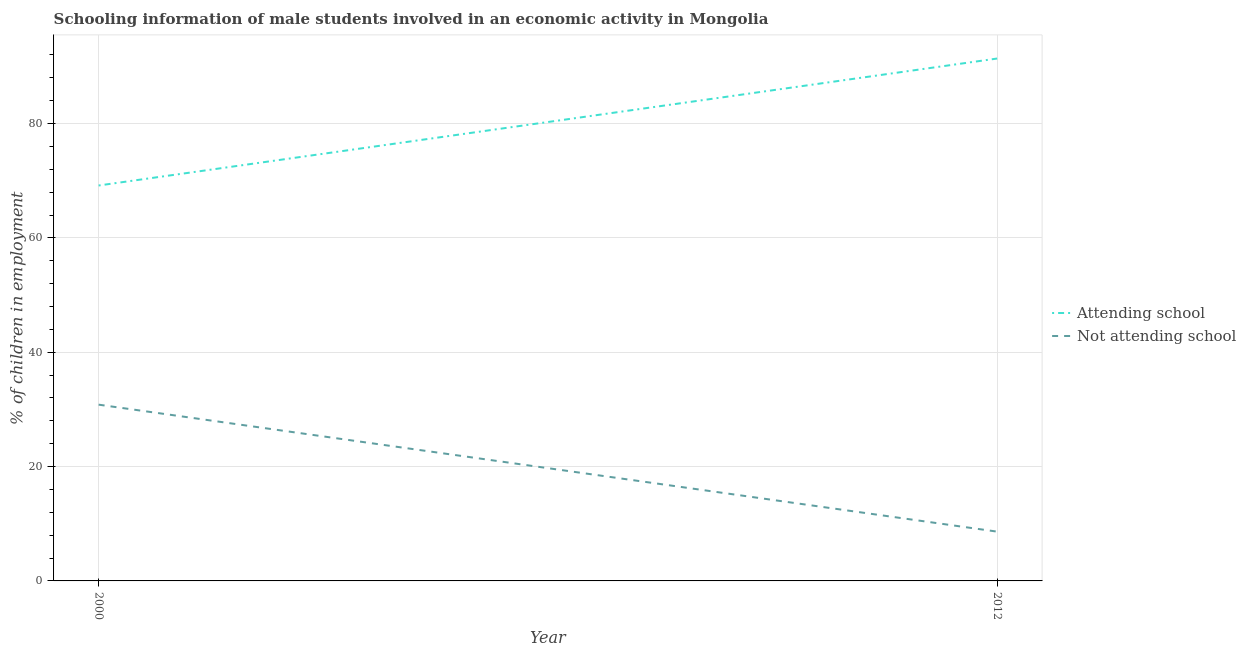How many different coloured lines are there?
Offer a very short reply. 2. Does the line corresponding to percentage of employed males who are not attending school intersect with the line corresponding to percentage of employed males who are attending school?
Keep it short and to the point. No. What is the percentage of employed males who are not attending school in 2012?
Offer a very short reply. 8.62. Across all years, what is the maximum percentage of employed males who are not attending school?
Give a very brief answer. 30.83. Across all years, what is the minimum percentage of employed males who are not attending school?
Make the answer very short. 8.62. What is the total percentage of employed males who are attending school in the graph?
Your response must be concise. 160.55. What is the difference between the percentage of employed males who are not attending school in 2000 and that in 2012?
Offer a terse response. 22.21. What is the difference between the percentage of employed males who are not attending school in 2012 and the percentage of employed males who are attending school in 2000?
Your response must be concise. -60.55. What is the average percentage of employed males who are not attending school per year?
Your response must be concise. 19.73. In the year 2000, what is the difference between the percentage of employed males who are attending school and percentage of employed males who are not attending school?
Your answer should be compact. 38.34. In how many years, is the percentage of employed males who are not attending school greater than 64 %?
Offer a very short reply. 0. What is the ratio of the percentage of employed males who are not attending school in 2000 to that in 2012?
Your answer should be very brief. 3.58. Is the percentage of employed males who are attending school in 2000 less than that in 2012?
Provide a short and direct response. Yes. In how many years, is the percentage of employed males who are not attending school greater than the average percentage of employed males who are not attending school taken over all years?
Ensure brevity in your answer.  1. Does the percentage of employed males who are attending school monotonically increase over the years?
Provide a succinct answer. Yes. Is the percentage of employed males who are attending school strictly greater than the percentage of employed males who are not attending school over the years?
Offer a terse response. Yes. Is the percentage of employed males who are attending school strictly less than the percentage of employed males who are not attending school over the years?
Keep it short and to the point. No. How many years are there in the graph?
Offer a very short reply. 2. Does the graph contain any zero values?
Offer a terse response. No. Where does the legend appear in the graph?
Make the answer very short. Center right. How many legend labels are there?
Your answer should be compact. 2. How are the legend labels stacked?
Your answer should be very brief. Vertical. What is the title of the graph?
Provide a short and direct response. Schooling information of male students involved in an economic activity in Mongolia. Does "Under-5(female)" appear as one of the legend labels in the graph?
Keep it short and to the point. No. What is the label or title of the X-axis?
Provide a short and direct response. Year. What is the label or title of the Y-axis?
Provide a succinct answer. % of children in employment. What is the % of children in employment of Attending school in 2000?
Your answer should be compact. 69.17. What is the % of children in employment in Not attending school in 2000?
Make the answer very short. 30.83. What is the % of children in employment of Attending school in 2012?
Ensure brevity in your answer.  91.38. What is the % of children in employment of Not attending school in 2012?
Make the answer very short. 8.62. Across all years, what is the maximum % of children in employment in Attending school?
Ensure brevity in your answer.  91.38. Across all years, what is the maximum % of children in employment in Not attending school?
Your answer should be very brief. 30.83. Across all years, what is the minimum % of children in employment of Attending school?
Offer a terse response. 69.17. Across all years, what is the minimum % of children in employment of Not attending school?
Offer a terse response. 8.62. What is the total % of children in employment in Attending school in the graph?
Ensure brevity in your answer.  160.55. What is the total % of children in employment in Not attending school in the graph?
Offer a terse response. 39.45. What is the difference between the % of children in employment in Attending school in 2000 and that in 2012?
Keep it short and to the point. -22.21. What is the difference between the % of children in employment in Not attending school in 2000 and that in 2012?
Ensure brevity in your answer.  22.21. What is the difference between the % of children in employment in Attending school in 2000 and the % of children in employment in Not attending school in 2012?
Your response must be concise. 60.55. What is the average % of children in employment in Attending school per year?
Provide a succinct answer. 80.27. What is the average % of children in employment in Not attending school per year?
Provide a short and direct response. 19.73. In the year 2000, what is the difference between the % of children in employment of Attending school and % of children in employment of Not attending school?
Give a very brief answer. 38.34. In the year 2012, what is the difference between the % of children in employment in Attending school and % of children in employment in Not attending school?
Offer a very short reply. 82.76. What is the ratio of the % of children in employment of Attending school in 2000 to that in 2012?
Make the answer very short. 0.76. What is the ratio of the % of children in employment of Not attending school in 2000 to that in 2012?
Your answer should be compact. 3.58. What is the difference between the highest and the second highest % of children in employment of Attending school?
Keep it short and to the point. 22.21. What is the difference between the highest and the second highest % of children in employment in Not attending school?
Keep it short and to the point. 22.21. What is the difference between the highest and the lowest % of children in employment of Attending school?
Offer a terse response. 22.21. What is the difference between the highest and the lowest % of children in employment in Not attending school?
Your response must be concise. 22.21. 